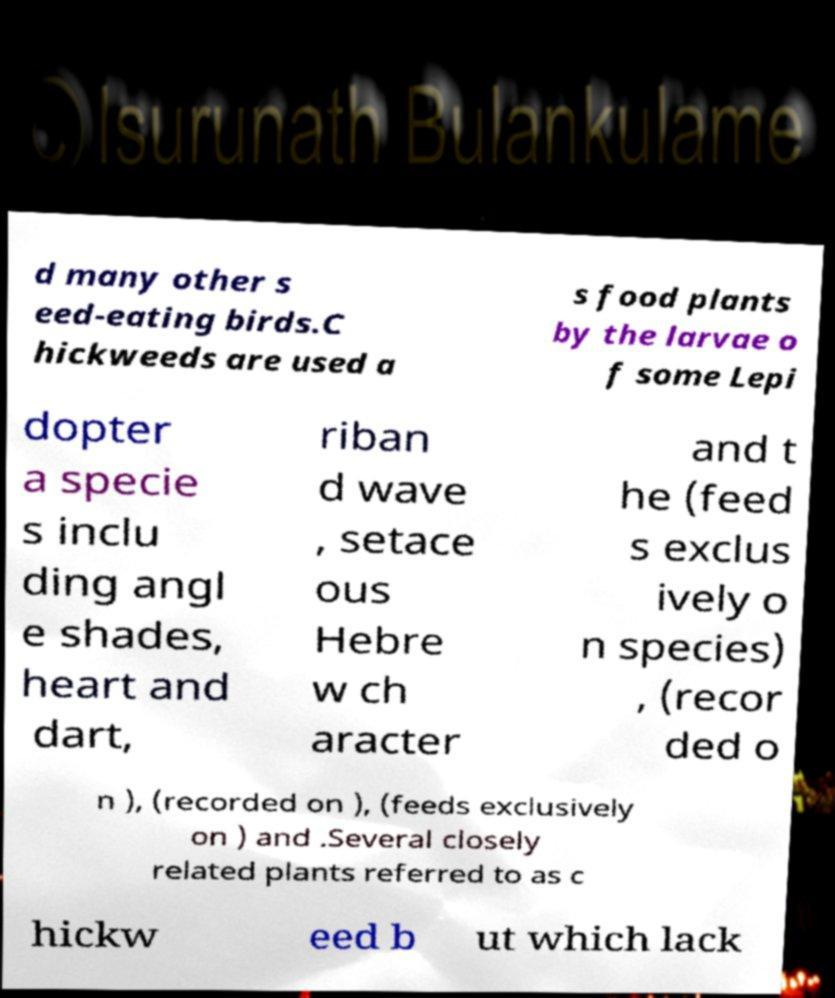Please identify and transcribe the text found in this image. d many other s eed-eating birds.C hickweeds are used a s food plants by the larvae o f some Lepi dopter a specie s inclu ding angl e shades, heart and dart, riban d wave , setace ous Hebre w ch aracter and t he (feed s exclus ively o n species) , (recor ded o n ), (recorded on ), (feeds exclusively on ) and .Several closely related plants referred to as c hickw eed b ut which lack 